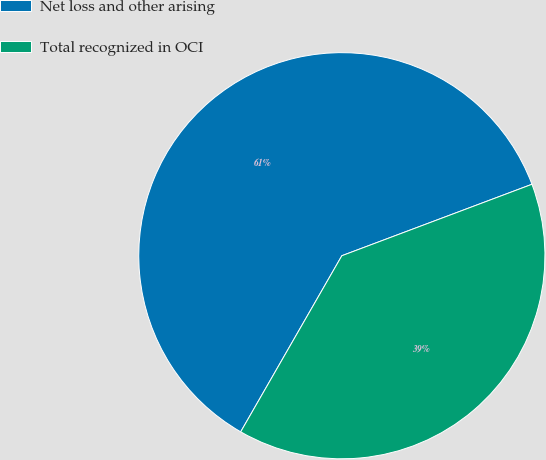<chart> <loc_0><loc_0><loc_500><loc_500><pie_chart><fcel>Net loss and other arising<fcel>Total recognized in OCI<nl><fcel>60.98%<fcel>39.02%<nl></chart> 